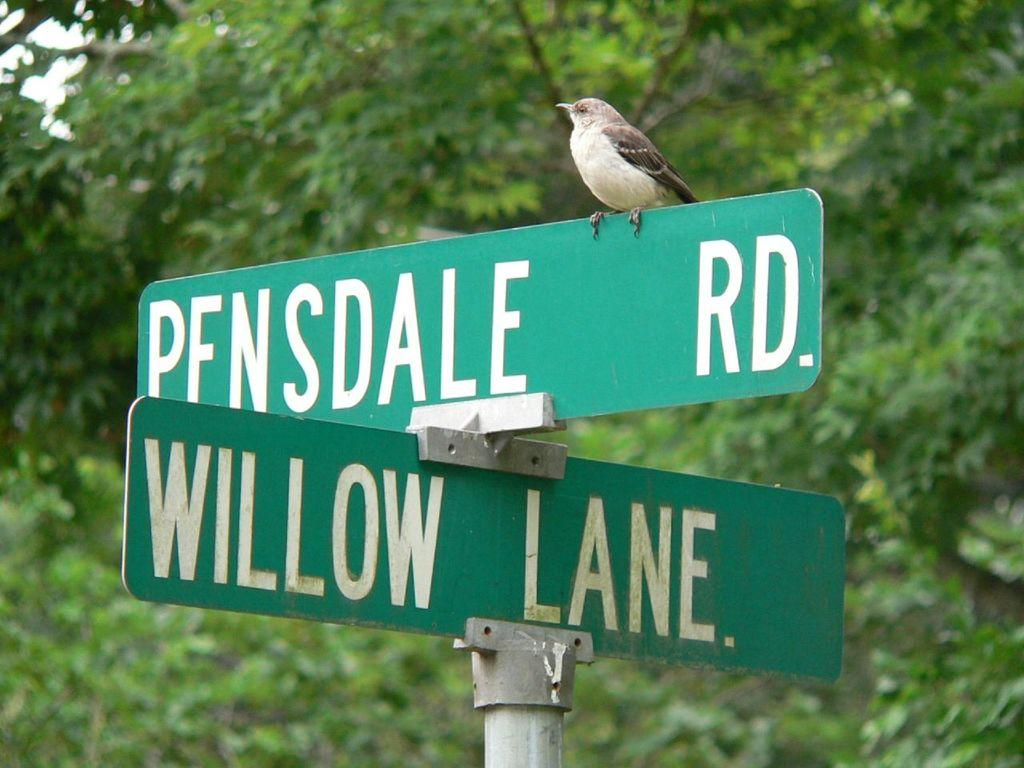What is attached to the pole in the image? There are name boards on a pole in the image. Is there any animal depicted on the name boards? Yes, a bird is present on the name board. What can be seen in the background of the image? There are trees and the sky visible in the background of the image. What type of oil is being used by the bird on the name board? There is no oil present in the image, and the bird is not performing any action that would involve the use of oil. 